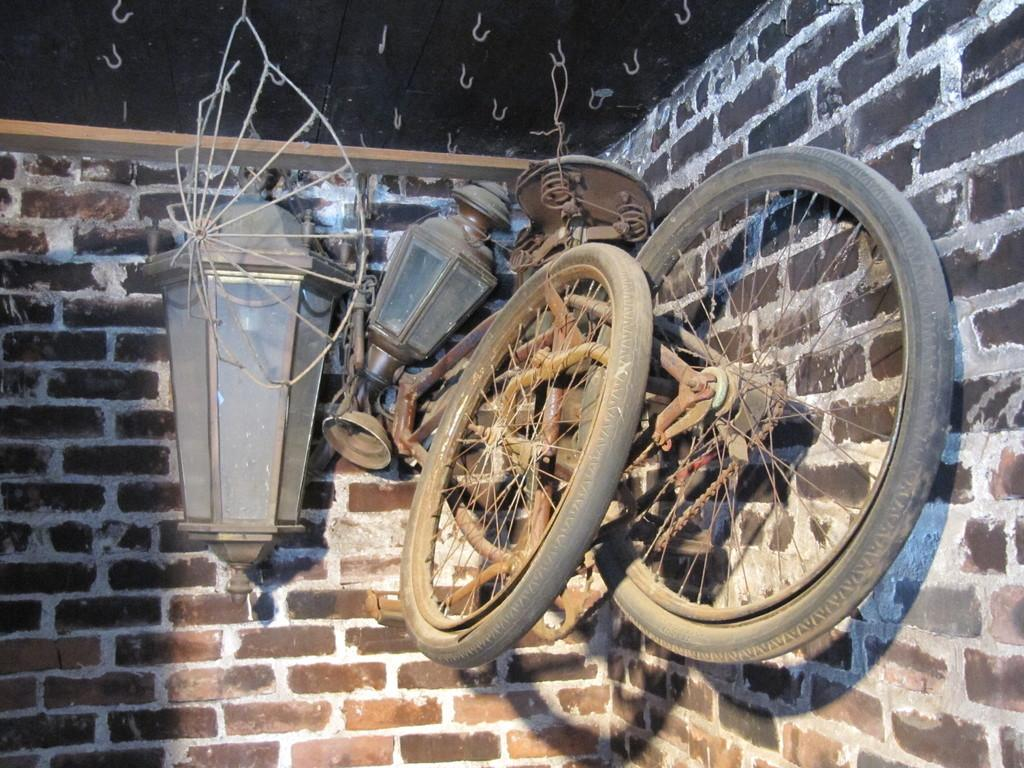What type of objects are attached to the bicycles in the image? There are wheels of bicycles in the image. What type of lighting is present in the image? Two lamps are hanging near the brick wall. What can be seen in the ceiling of the image? There are hooks in the ceiling. What color is the mist surrounding the bicycles in the image? There is no mist present in the image; it features wheels of bicycles, lamps, and hooks. Can you see a sock hanging from one of the hooks in the image? There is no sock present in the image. 